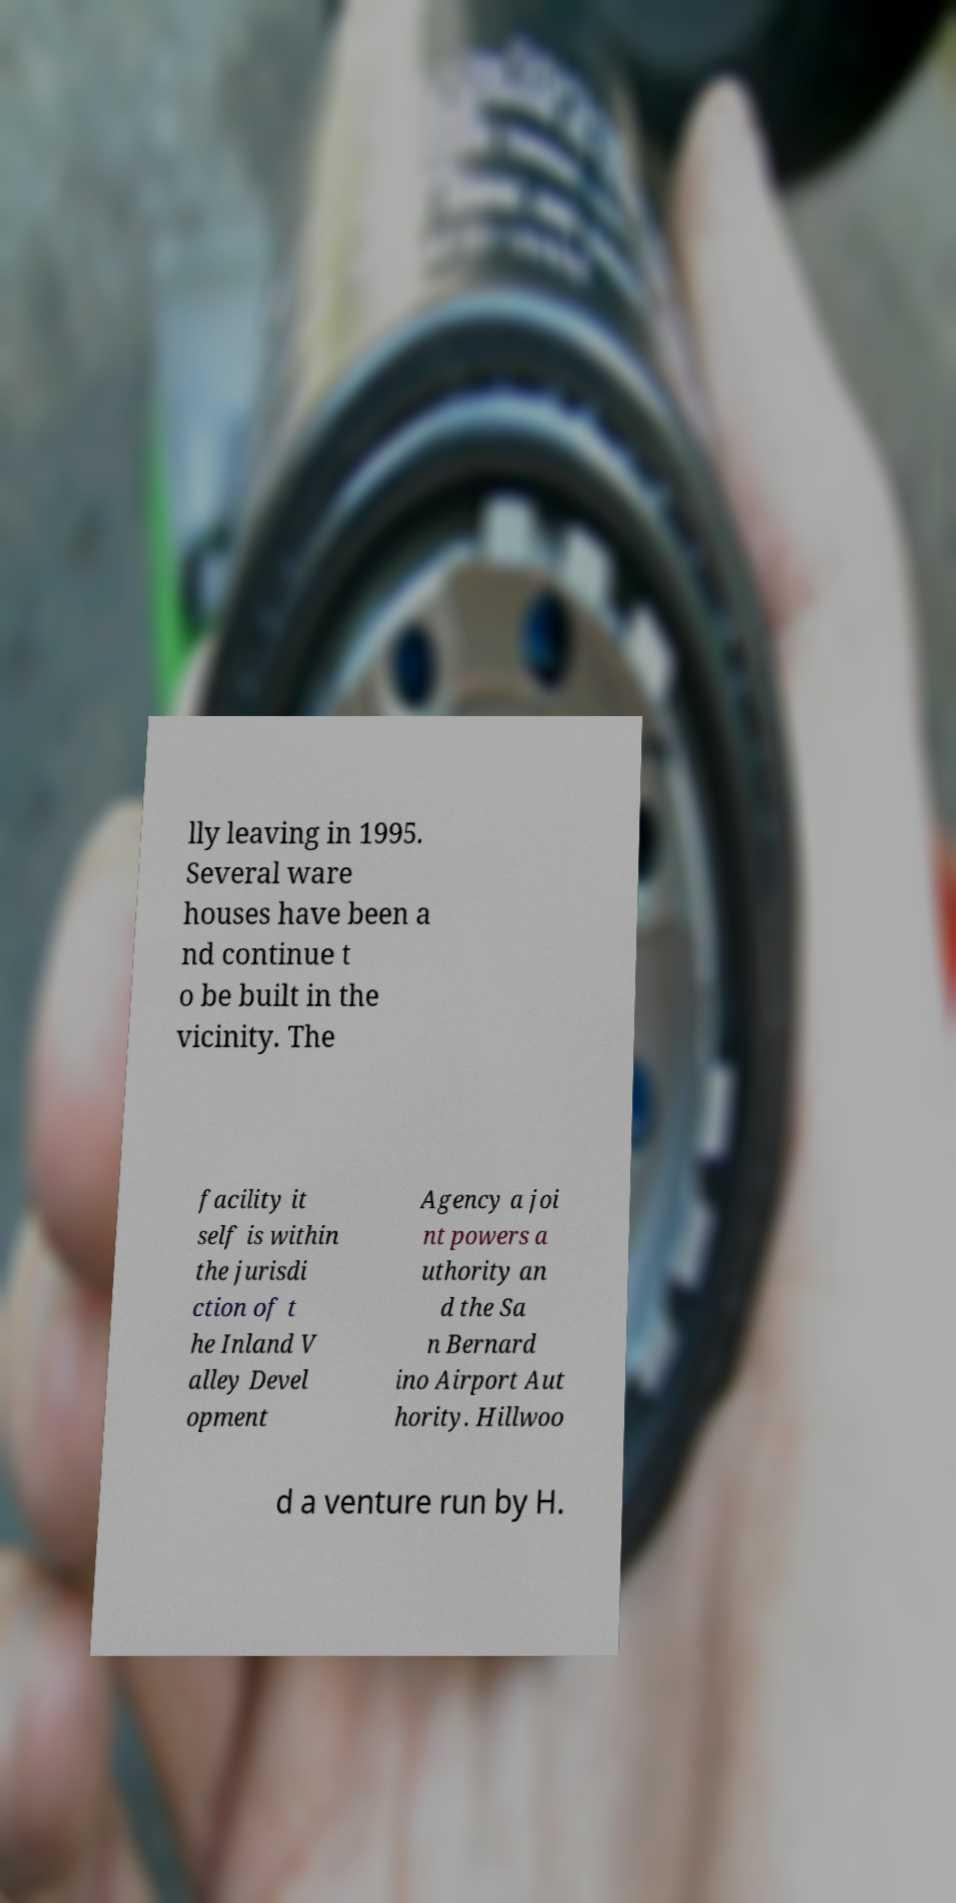Can you accurately transcribe the text from the provided image for me? lly leaving in 1995. Several ware houses have been a nd continue t o be built in the vicinity. The facility it self is within the jurisdi ction of t he Inland V alley Devel opment Agency a joi nt powers a uthority an d the Sa n Bernard ino Airport Aut hority. Hillwoo d a venture run by H. 